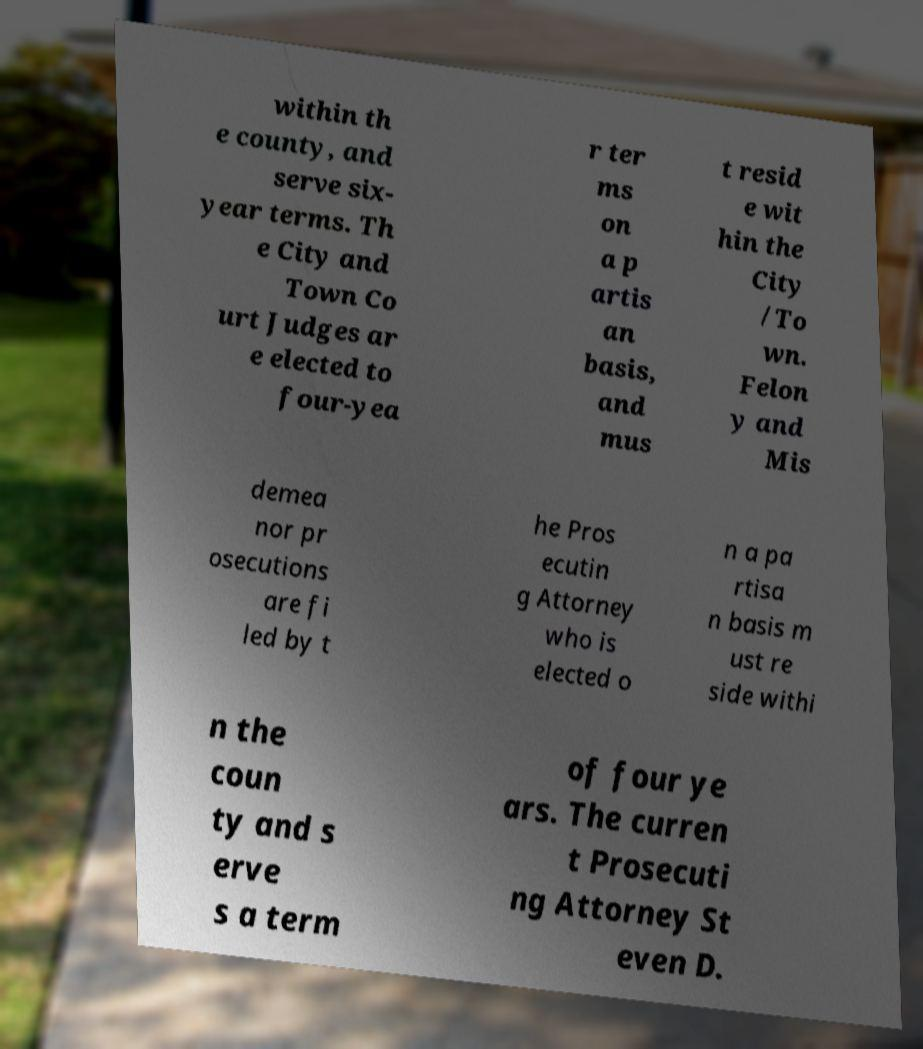I need the written content from this picture converted into text. Can you do that? within th e county, and serve six- year terms. Th e City and Town Co urt Judges ar e elected to four-yea r ter ms on a p artis an basis, and mus t resid e wit hin the City /To wn. Felon y and Mis demea nor pr osecutions are fi led by t he Pros ecutin g Attorney who is elected o n a pa rtisa n basis m ust re side withi n the coun ty and s erve s a term of four ye ars. The curren t Prosecuti ng Attorney St even D. 